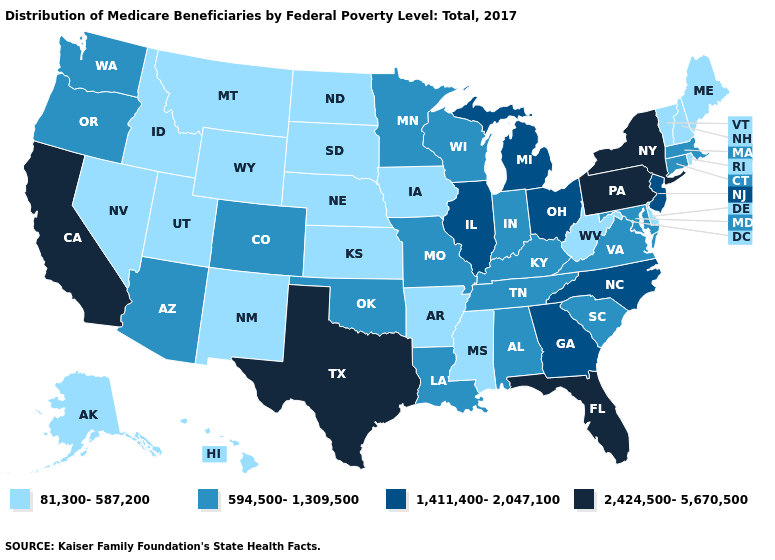Which states have the highest value in the USA?
Concise answer only. California, Florida, New York, Pennsylvania, Texas. What is the value of Arizona?
Short answer required. 594,500-1,309,500. Does the first symbol in the legend represent the smallest category?
Concise answer only. Yes. How many symbols are there in the legend?
Answer briefly. 4. What is the value of South Carolina?
Answer briefly. 594,500-1,309,500. How many symbols are there in the legend?
Be succinct. 4. Name the states that have a value in the range 1,411,400-2,047,100?
Be succinct. Georgia, Illinois, Michigan, New Jersey, North Carolina, Ohio. What is the value of Georgia?
Give a very brief answer. 1,411,400-2,047,100. What is the value of Kentucky?
Answer briefly. 594,500-1,309,500. What is the highest value in the USA?
Answer briefly. 2,424,500-5,670,500. Among the states that border Arizona , which have the lowest value?
Write a very short answer. Nevada, New Mexico, Utah. Which states have the lowest value in the USA?
Keep it brief. Alaska, Arkansas, Delaware, Hawaii, Idaho, Iowa, Kansas, Maine, Mississippi, Montana, Nebraska, Nevada, New Hampshire, New Mexico, North Dakota, Rhode Island, South Dakota, Utah, Vermont, West Virginia, Wyoming. What is the value of Utah?
Concise answer only. 81,300-587,200. Does West Virginia have the lowest value in the USA?
Short answer required. Yes. Among the states that border Delaware , which have the highest value?
Quick response, please. Pennsylvania. 